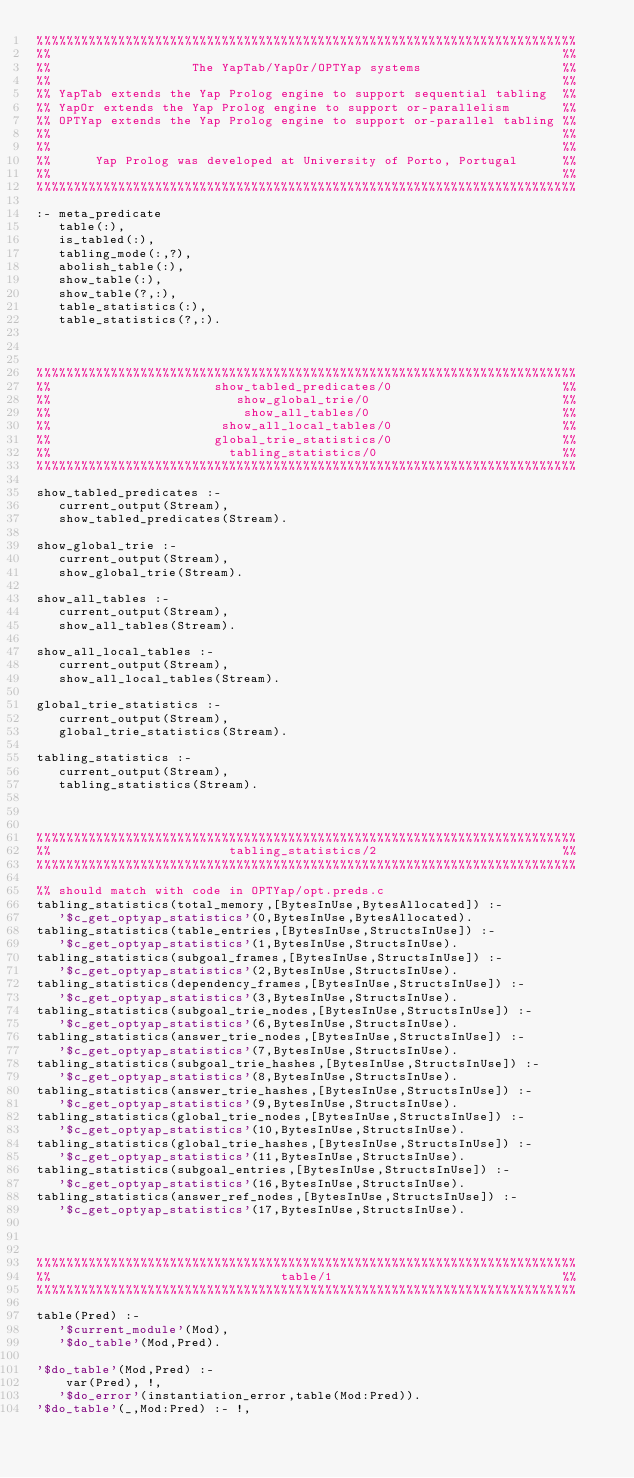Convert code to text. <code><loc_0><loc_0><loc_500><loc_500><_Prolog_>%%%%%%%%%%%%%%%%%%%%%%%%%%%%%%%%%%%%%%%%%%%%%%%%%%%%%%%%%%%%%%%%%%%%%%%%%
%%                                                                     %%
%%                   The YapTab/YapOr/OPTYap systems                   %%
%%                                                                     %%
%% YapTab extends the Yap Prolog engine to support sequential tabling  %%
%% YapOr extends the Yap Prolog engine to support or-parallelism       %%
%% OPTYap extends the Yap Prolog engine to support or-parallel tabling %%
%%                                                                     %%
%%                                                                     %%
%%      Yap Prolog was developed at University of Porto, Portugal      %%
%%                                                                     %%
%%%%%%%%%%%%%%%%%%%%%%%%%%%%%%%%%%%%%%%%%%%%%%%%%%%%%%%%%%%%%%%%%%%%%%%%%

:- meta_predicate 
   table(:), 
   is_tabled(:), 
   tabling_mode(:,?), 
   abolish_table(:), 
   show_table(:), 
   show_table(?,:), 
   table_statistics(:),
   table_statistics(?,:).



%%%%%%%%%%%%%%%%%%%%%%%%%%%%%%%%%%%%%%%%%%%%%%%%%%%%%%%%%%%%%%%%%%%%%%%%%
%%                      show_tabled_predicates/0                       %%
%%                         show_global_trie/0                          %%
%%                          show_all_tables/0                          %%
%%                       show_all_local_tables/0                       %%
%%                      global_trie_statistics/0                       %%
%%                        tabling_statistics/0                         %%
%%%%%%%%%%%%%%%%%%%%%%%%%%%%%%%%%%%%%%%%%%%%%%%%%%%%%%%%%%%%%%%%%%%%%%%%%

show_tabled_predicates :- 
   current_output(Stream),
   show_tabled_predicates(Stream).

show_global_trie :-
   current_output(Stream),
   show_global_trie(Stream).

show_all_tables :-
   current_output(Stream),
   show_all_tables(Stream).

show_all_local_tables :-
   current_output(Stream),
   show_all_local_tables(Stream).

global_trie_statistics :-
   current_output(Stream),
   global_trie_statistics(Stream).

tabling_statistics :-
   current_output(Stream),
   tabling_statistics(Stream).



%%%%%%%%%%%%%%%%%%%%%%%%%%%%%%%%%%%%%%%%%%%%%%%%%%%%%%%%%%%%%%%%%%%%%%%%%
%%                        tabling_statistics/2                         %%
%%%%%%%%%%%%%%%%%%%%%%%%%%%%%%%%%%%%%%%%%%%%%%%%%%%%%%%%%%%%%%%%%%%%%%%%%

%% should match with code in OPTYap/opt.preds.c
tabling_statistics(total_memory,[BytesInUse,BytesAllocated]) :-
   '$c_get_optyap_statistics'(0,BytesInUse,BytesAllocated).
tabling_statistics(table_entries,[BytesInUse,StructsInUse]) :-
   '$c_get_optyap_statistics'(1,BytesInUse,StructsInUse).
tabling_statistics(subgoal_frames,[BytesInUse,StructsInUse]) :-
   '$c_get_optyap_statistics'(2,BytesInUse,StructsInUse).
tabling_statistics(dependency_frames,[BytesInUse,StructsInUse]) :-
   '$c_get_optyap_statistics'(3,BytesInUse,StructsInUse).
tabling_statistics(subgoal_trie_nodes,[BytesInUse,StructsInUse]) :-
   '$c_get_optyap_statistics'(6,BytesInUse,StructsInUse).
tabling_statistics(answer_trie_nodes,[BytesInUse,StructsInUse]) :-
   '$c_get_optyap_statistics'(7,BytesInUse,StructsInUse).
tabling_statistics(subgoal_trie_hashes,[BytesInUse,StructsInUse]) :-
   '$c_get_optyap_statistics'(8,BytesInUse,StructsInUse).
tabling_statistics(answer_trie_hashes,[BytesInUse,StructsInUse]) :-
   '$c_get_optyap_statistics'(9,BytesInUse,StructsInUse).
tabling_statistics(global_trie_nodes,[BytesInUse,StructsInUse]) :-
   '$c_get_optyap_statistics'(10,BytesInUse,StructsInUse).
tabling_statistics(global_trie_hashes,[BytesInUse,StructsInUse]) :-
   '$c_get_optyap_statistics'(11,BytesInUse,StructsInUse).
tabling_statistics(subgoal_entries,[BytesInUse,StructsInUse]) :-
   '$c_get_optyap_statistics'(16,BytesInUse,StructsInUse).
tabling_statistics(answer_ref_nodes,[BytesInUse,StructsInUse]) :-
   '$c_get_optyap_statistics'(17,BytesInUse,StructsInUse).



%%%%%%%%%%%%%%%%%%%%%%%%%%%%%%%%%%%%%%%%%%%%%%%%%%%%%%%%%%%%%%%%%%%%%%%%%
%%                               table/1                               %%
%%%%%%%%%%%%%%%%%%%%%%%%%%%%%%%%%%%%%%%%%%%%%%%%%%%%%%%%%%%%%%%%%%%%%%%%%

table(Pred) :-
   '$current_module'(Mod),
   '$do_table'(Mod,Pred).

'$do_table'(Mod,Pred) :-
    var(Pred), !,
   '$do_error'(instantiation_error,table(Mod:Pred)).
'$do_table'(_,Mod:Pred) :- !,</code> 